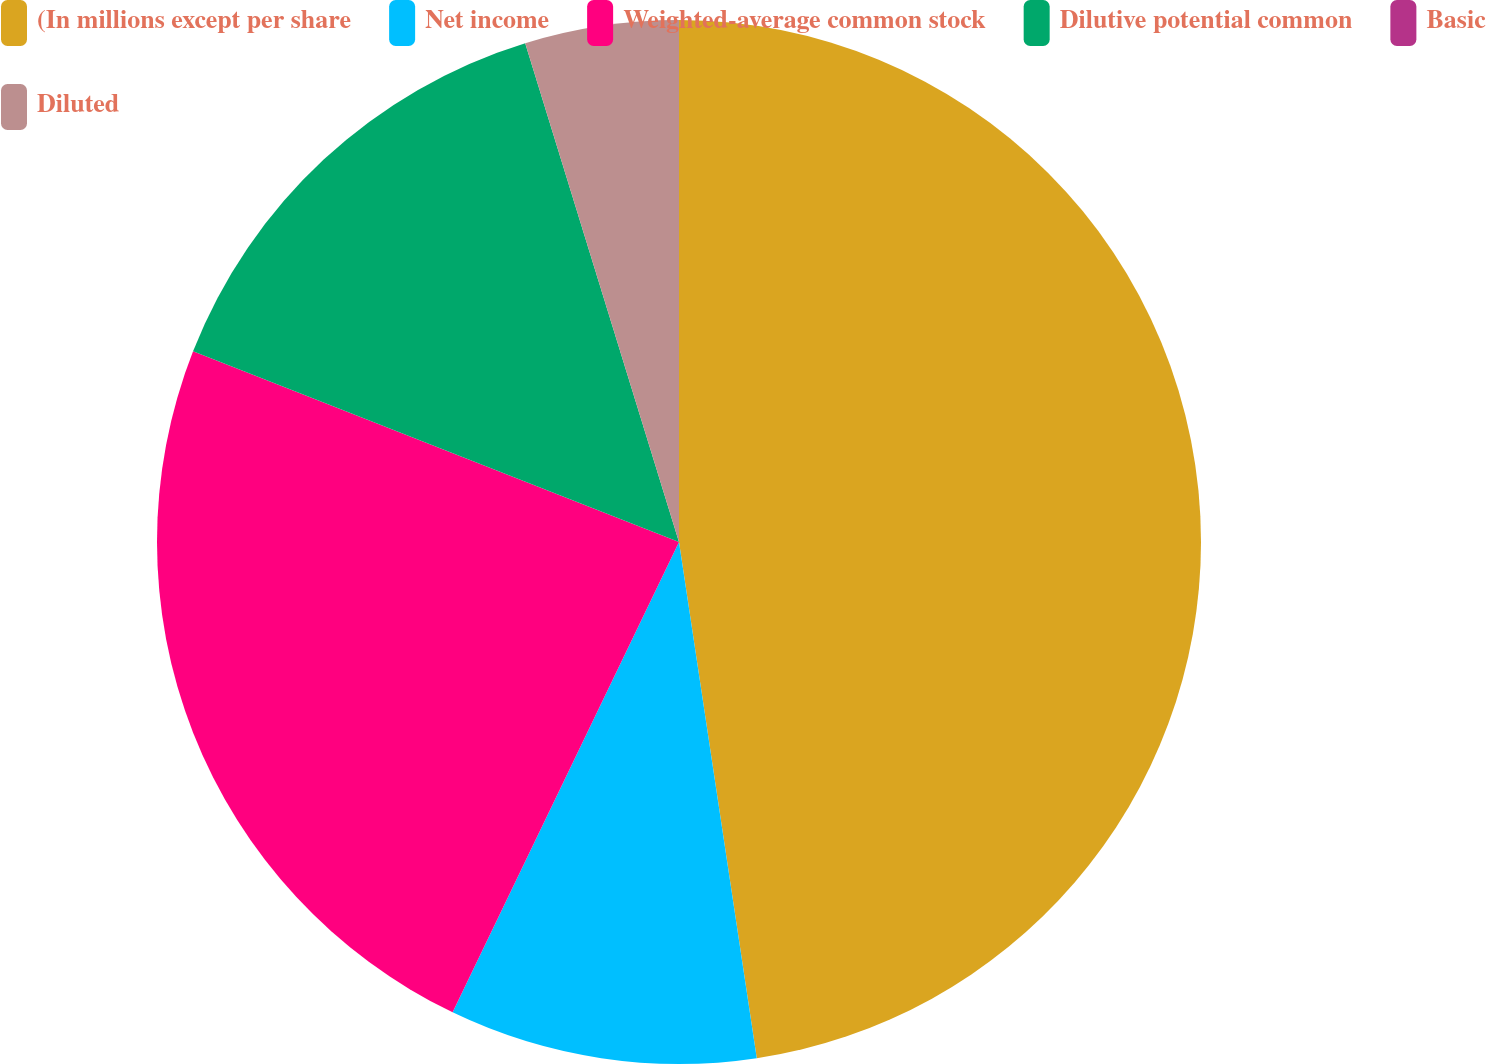Convert chart to OTSL. <chart><loc_0><loc_0><loc_500><loc_500><pie_chart><fcel>(In millions except per share<fcel>Net income<fcel>Weighted-average common stock<fcel>Dilutive potential common<fcel>Basic<fcel>Diluted<nl><fcel>47.62%<fcel>9.52%<fcel>23.81%<fcel>14.29%<fcel>0.0%<fcel>4.76%<nl></chart> 